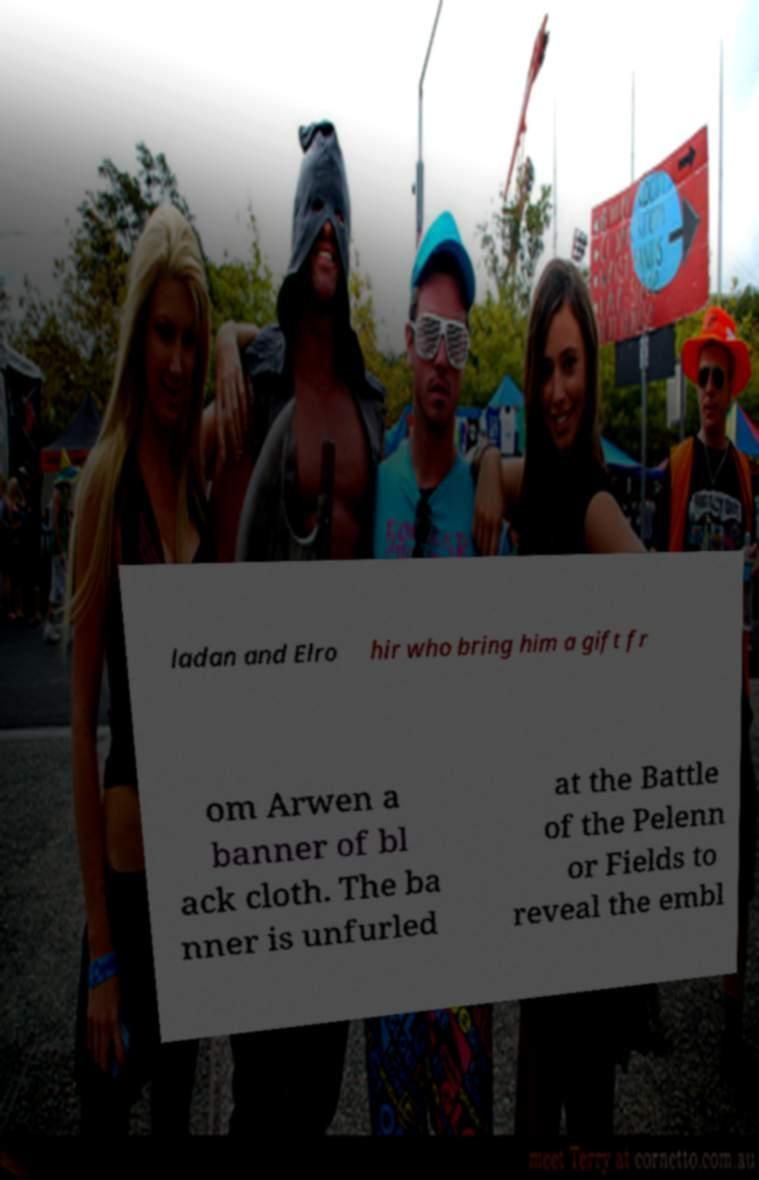Please read and relay the text visible in this image. What does it say? ladan and Elro hir who bring him a gift fr om Arwen a banner of bl ack cloth. The ba nner is unfurled at the Battle of the Pelenn or Fields to reveal the embl 